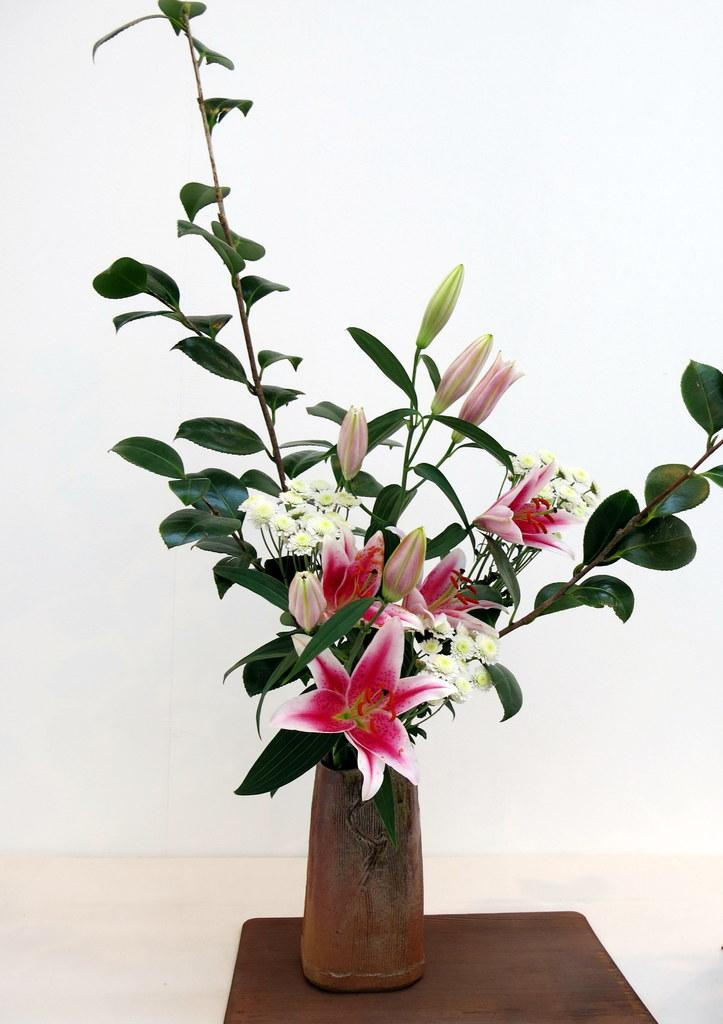What is placed on the stool in the image? There is a flower vase placed on a stool. What month is depicted in the image? There is no month depicted in the image; it features a flower vase placed on a stool. What type of glass is being used to hold the flowers in the image? There is no glass present in the image; it is a flower vase placed on a stool. 